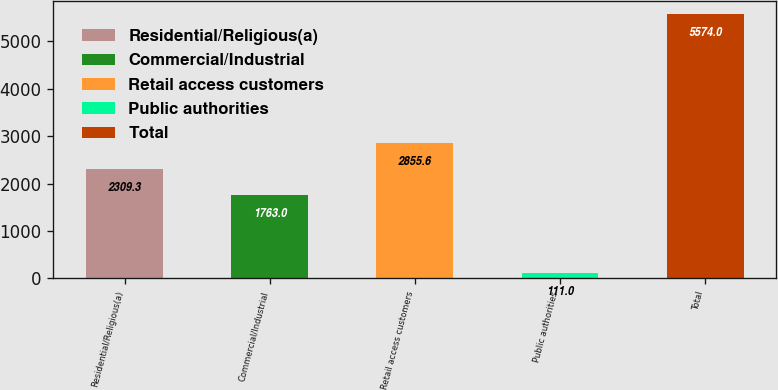Convert chart to OTSL. <chart><loc_0><loc_0><loc_500><loc_500><bar_chart><fcel>Residential/Religious(a)<fcel>Commercial/Industrial<fcel>Retail access customers<fcel>Public authorities<fcel>Total<nl><fcel>2309.3<fcel>1763<fcel>2855.6<fcel>111<fcel>5574<nl></chart> 